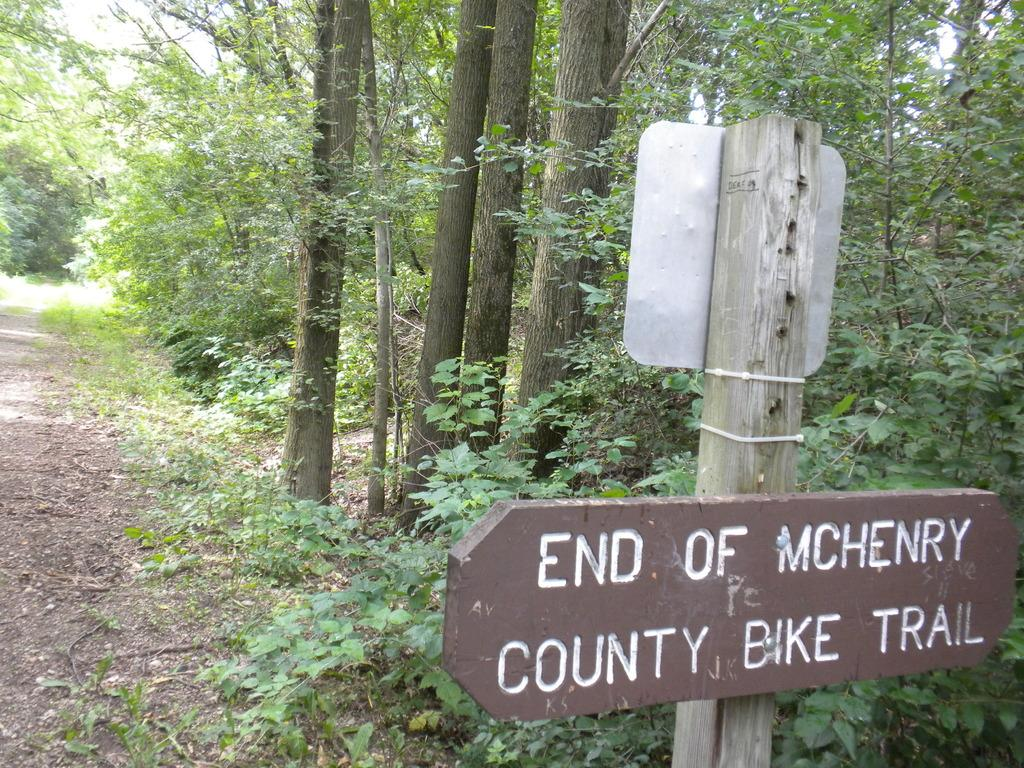What can be seen on the right side of the image? There are sign boards on the right side of the image. What is visible in the background of the image? There are plants and trees in the background of the image. Can you tell me how many wings are attached to the plants in the image? There are no wings present in the image; it features sign boards, plants, and trees. What type of machine is visible in the background of the image? There is no machine present in the image; it features plants and trees in the background. 